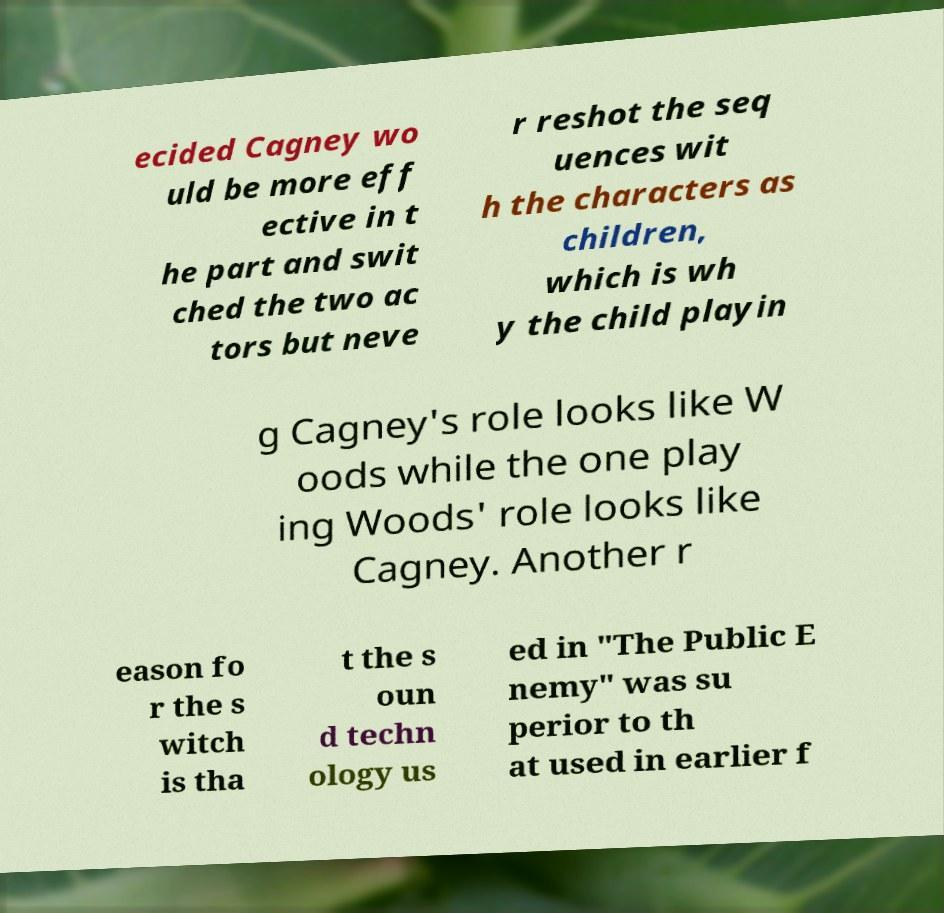Please identify and transcribe the text found in this image. ecided Cagney wo uld be more eff ective in t he part and swit ched the two ac tors but neve r reshot the seq uences wit h the characters as children, which is wh y the child playin g Cagney's role looks like W oods while the one play ing Woods' role looks like Cagney. Another r eason fo r the s witch is tha t the s oun d techn ology us ed in "The Public E nemy" was su perior to th at used in earlier f 